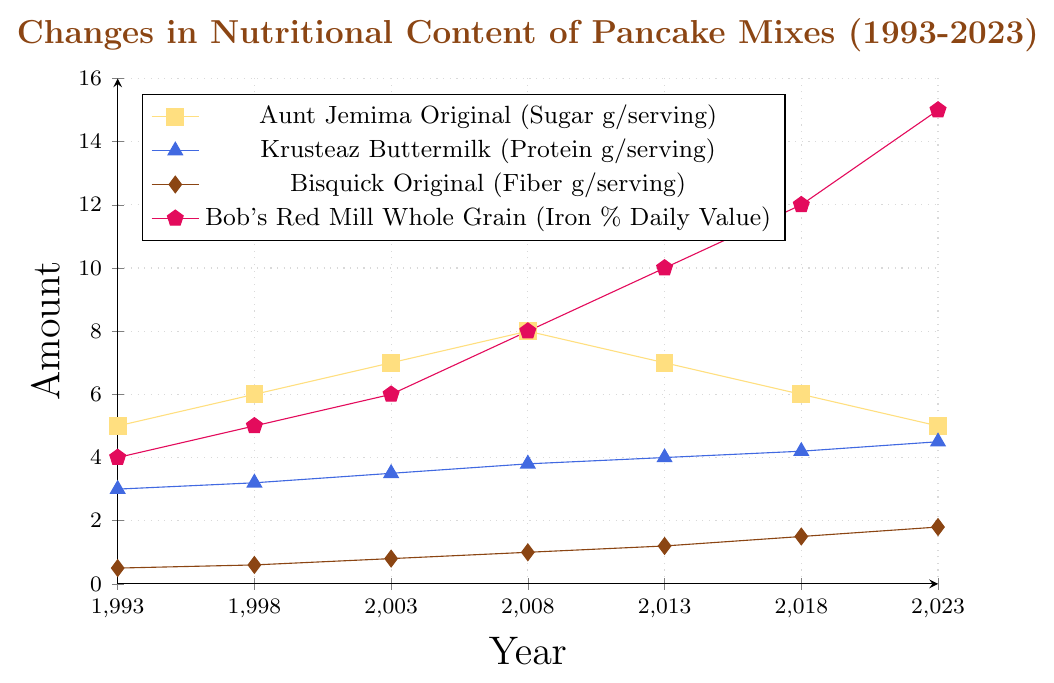What was the sugar content in Aunt Jemima Original pancake mix in 1993, 2013, and 2023? Look at the figure and find the points corresponding to 1993, 2013, and 2023 for Aunt Jemima Original (usually marked with a specific color like yellow). Read the values from the y-axis for these years.
Answer: 5g, 7g, 5g Which pancake mix has had the most significant increase in its nutritional content over the period from 1993 to 2023? Compare each mix by calculating the difference between the values for 1993 and 2023. Aunt Jemima Original (Sugar): 5 to 5 (0 increase), Krusteaz Buttermilk (Protein): 3 to 4.5 (1.5 increase), Bisquick Original (Fiber): 0.5 to 1.8 (1.3 increase), Bob's Red Mill Whole Grain (Iron % DV): 4 to 15 (11 increase). Bob's Red Mill Whole Grain has the most significant increase.
Answer: Bob's Red Mill Whole Grain How much has the protein content in Krusteaz Buttermilk pancake mix increased from 2003 to 2023? Find the values for Krusteaz Buttermilk (Protein) in 2003 and 2023. Protein in 2003 is 3.5g, and in 2023 it is 4.5g. Subtract the value in 2003 from the value in 2023 to find the increase. 4.5 - 3.5 = 1
Answer: 1g What is the average fiber content in Bisquick Original pancake mix over the years 1993, 2008, and 2023? Find the values for Bisquick Original (Fiber) in 1993, 2008, and 2023. The values are 0.5g, 1g, and 1.8g respectively. Add these values and divide by the number of values to find the average: (0.5 + 1 + 1.8) / 3 = 1.1
Answer: 1.1g Compare the sugar content in Aunt Jemima Original and the iron content in Bob's Red Mill Whole Grain in 2008. Find the values for both the mixes in 2008. Sugar in Aunt Jemima Original is 8g and iron % DV in Bob's Red Mill Whole Grain is 8%. Compare these two values to see they are equal.
Answer: Equal What year did Bisquick Original pancake mix reach 1.2g of fiber? Find the year corresponding to the fiber content of 1.2g for Bisquick Original (usually marked by a specific color) by reading the point from the x-axis.
Answer: 2013 Which mix had a higher value in 2018, Krusteaz Buttermilk (Protein) or Bisquick Original (Fiber)? Compare the values of Krusteaz Buttermilk (Protein) and Bisquick Original (Fiber) in 2018. Krusteaz Buttermilk has 4.2g of protein, while Bisquick Original has 1.5g of fiber. 4.2 is greater than 1.5
Answer: Krusteaz Buttermilk How has the iron content in Bob's Red Mill Whole Grain pancake mix changed from 1993 to 1998, and from 2013 to 2018? Calculate the difference in values for iron content for Bob's Red Mill Whole Grain between 1993 to 1998 and 2013 to 2018. From 1993 (4%) to 1998 (5%) is 1% increase. From 2013 (10%) to 2018 (12%) is 2% increase.
Answer: 1%, 2% What year did Aunt Jemima Original have the highest sugar content and what was the amount? Look for the peak value for sugar content in Aunt Jemima Original over the given period. The highest point is in 2008 with 8g.
Answer: 2008, 8g By how much did the fiber content in Bisquick Original pancake mix change from 1998 to 2023? Calculate the difference in fiber content in Bisquick Original between 1998 and 2023. Fiber content in 1998 is 0.6g and in 2023 is 1.8g. So, 1.8 - 0.6 = 1.2g
Answer: 1.2g 